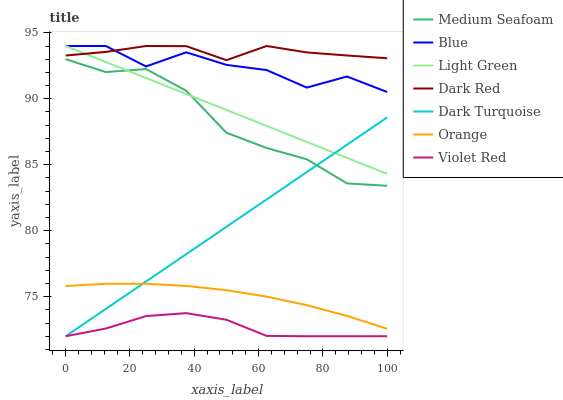Does Violet Red have the minimum area under the curve?
Answer yes or no. Yes. Does Dark Red have the maximum area under the curve?
Answer yes or no. Yes. Does Dark Red have the minimum area under the curve?
Answer yes or no. No. Does Violet Red have the maximum area under the curve?
Answer yes or no. No. Is Dark Turquoise the smoothest?
Answer yes or no. Yes. Is Blue the roughest?
Answer yes or no. Yes. Is Violet Red the smoothest?
Answer yes or no. No. Is Violet Red the roughest?
Answer yes or no. No. Does Violet Red have the lowest value?
Answer yes or no. Yes. Does Dark Red have the lowest value?
Answer yes or no. No. Does Light Green have the highest value?
Answer yes or no. Yes. Does Violet Red have the highest value?
Answer yes or no. No. Is Dark Turquoise less than Dark Red?
Answer yes or no. Yes. Is Blue greater than Orange?
Answer yes or no. Yes. Does Dark Turquoise intersect Light Green?
Answer yes or no. Yes. Is Dark Turquoise less than Light Green?
Answer yes or no. No. Is Dark Turquoise greater than Light Green?
Answer yes or no. No. Does Dark Turquoise intersect Dark Red?
Answer yes or no. No. 